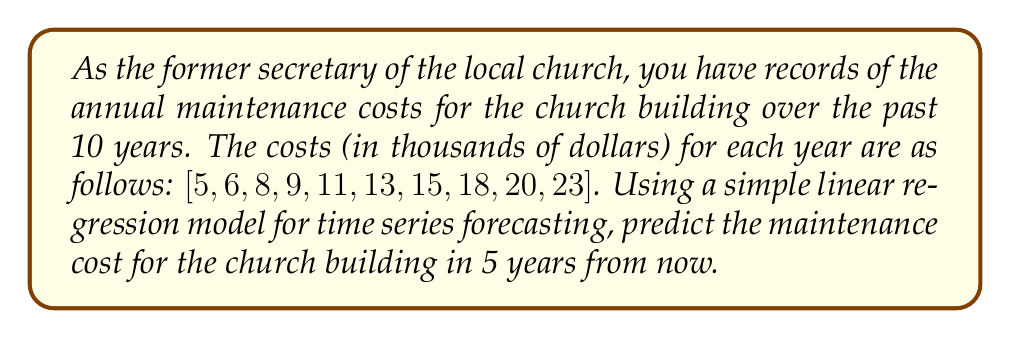Can you answer this question? To predict the future maintenance cost using simple linear regression, we'll follow these steps:

1. Assign time values (x) to each year, starting with 1 for the first year:
   x = [1, 2, 3, 4, 5, 6, 7, 8, 9, 10]
   y = [5, 6, 8, 9, 11, 13, 15, 18, 20, 23]

2. Calculate the means of x and y:
   $\bar{x} = \frac{1 + 2 + 3 + 4 + 5 + 6 + 7 + 8 + 9 + 10}{10} = 5.5$
   $\bar{y} = \frac{5 + 6 + 8 + 9 + 11 + 13 + 15 + 18 + 20 + 23}{10} = 12.8$

3. Calculate the slope (b) of the regression line:
   $$b = \frac{\sum_{i=1}^{n} (x_i - \bar{x})(y_i - \bar{y})}{\sum_{i=1}^{n} (x_i - \bar{x})^2}$$

   Numerator: $(1-5.5)(5-12.8) + (2-5.5)(6-12.8) + ... + (10-5.5)(23-12.8) = 412.5$
   Denominator: $(1-5.5)^2 + (2-5.5)^2 + ... + (10-5.5)^2 = 82.5$

   $b = \frac{412.5}{82.5} = 5$

4. Calculate the y-intercept (a):
   $a = \bar{y} - b\bar{x} = 12.8 - 5(5.5) = -14.7$

5. The regression line equation is:
   $y = 5x - 14.7$

6. To predict the maintenance cost in 5 years from now, we use x = 15 (10 + 5):
   $y = 5(15) - 14.7 = 60.3$

Therefore, the predicted maintenance cost in 5 years is approximately $60,300.
Answer: $60,300 